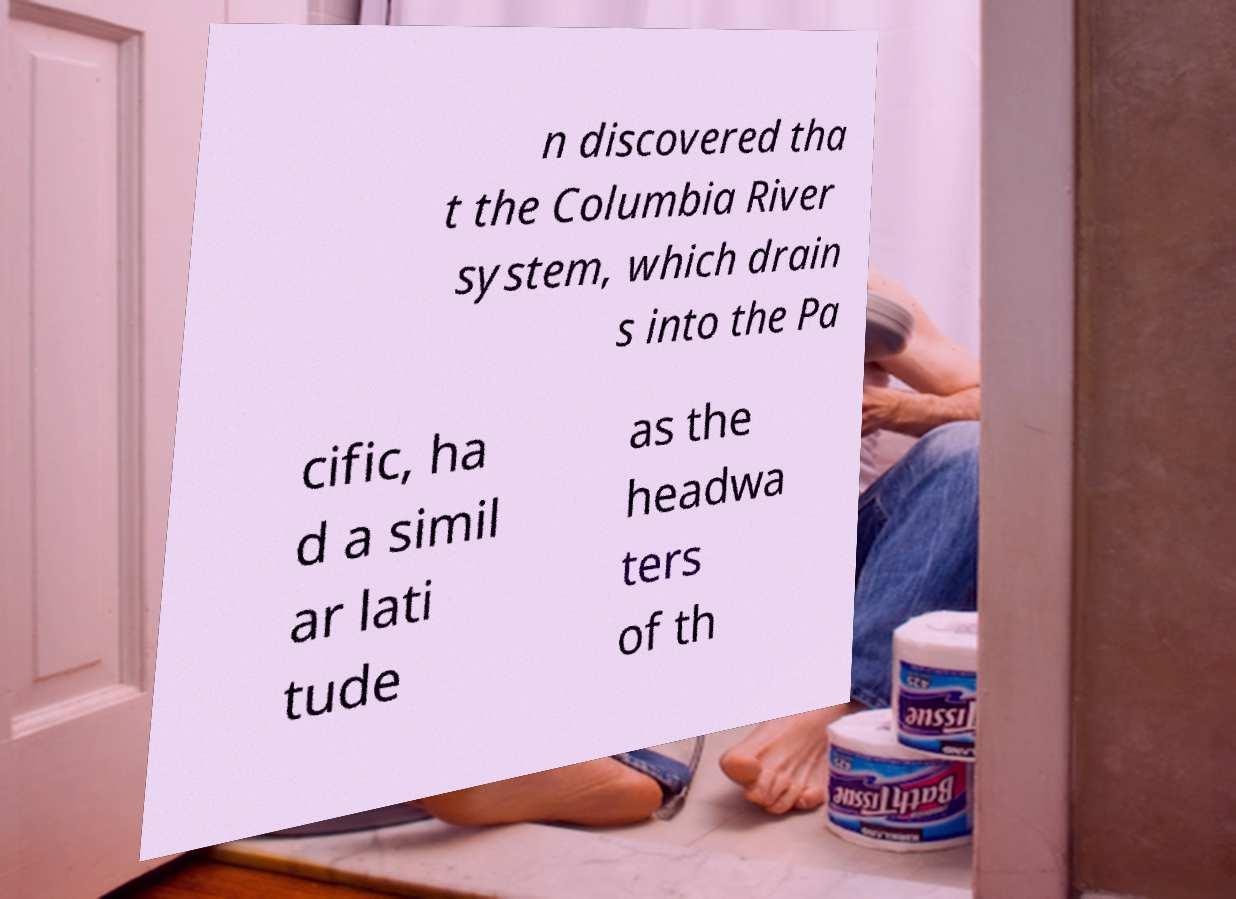There's text embedded in this image that I need extracted. Can you transcribe it verbatim? n discovered tha t the Columbia River system, which drain s into the Pa cific, ha d a simil ar lati tude as the headwa ters of th 